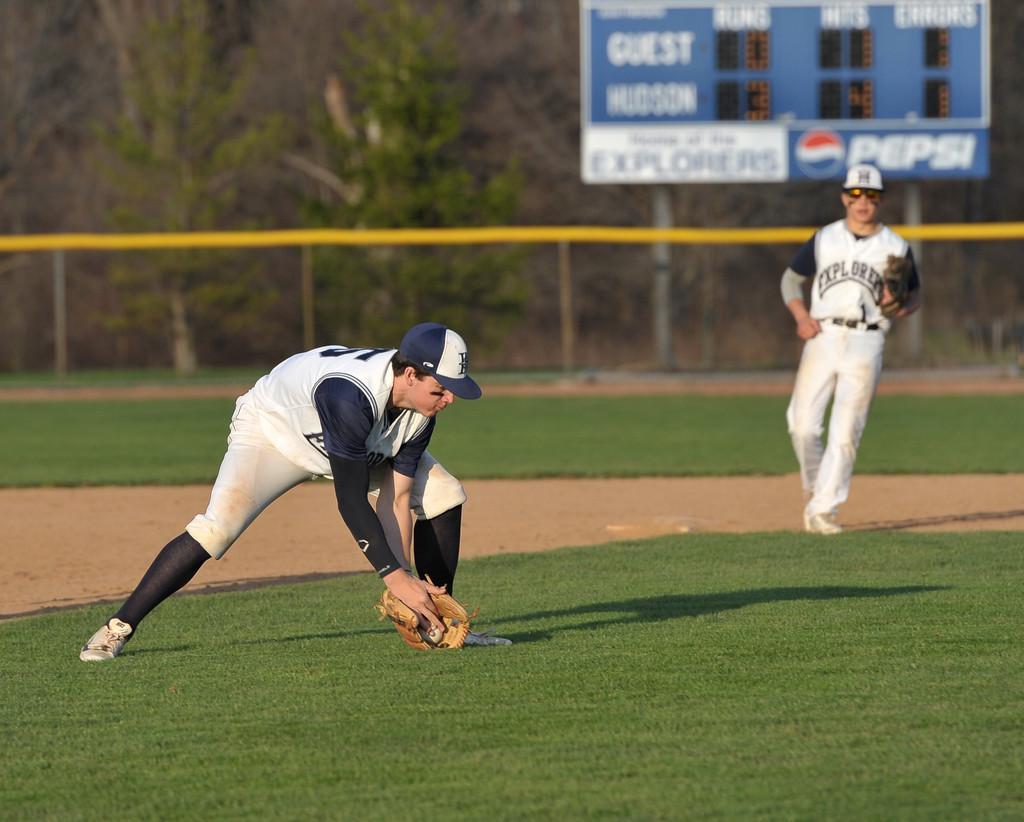In one or two sentences, can you explain what this image depicts? There is a man bending down, wearing a glove in one hand on the grassland, there is another person on the right side. There is a board, boundary, grassland and trees in the background. 